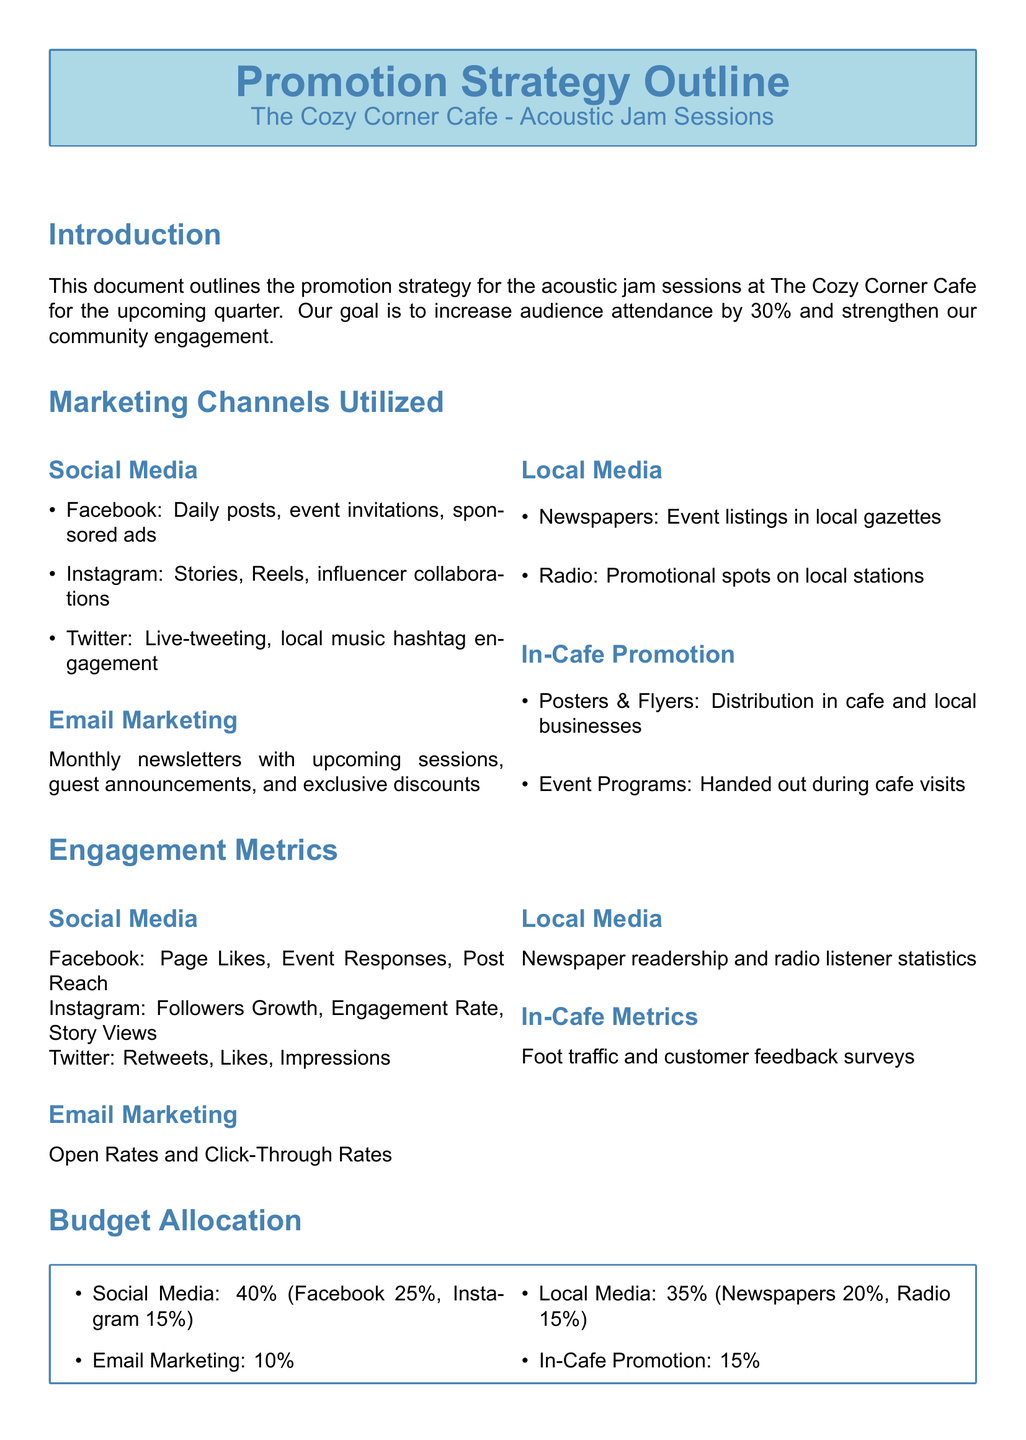What is the goal for audience attendance? The document states that the goal is to increase audience attendance by 30%.
Answer: 30% Which social media platform will receive the highest budget allocation? According to the budget allocation, Facebook will receive 25%, making it the highest.
Answer: Facebook What percentage of the budget is allocated to email marketing? The budget allocation specifies that email marketing will receive 10%.
Answer: 10% What engagement metric is used for Instagram? The document lists Followers Growth as one of the engagement metrics for Instagram.
Answer: Followers Growth How many marketing channels are listed in the document? The document outlines four marketing channels utilized for promotion.
Answer: Four What type of media will receive 20% of the budget allocation? The budget distribution indicates that newspapers will receive 20%.
Answer: Newspapers What kind of promotional materials are specified for in-cafe promotion? The document mentions posters and flyers as part of the in-cafe promotion strategy.
Answer: Posters & Flyers What are the engagement metrics for email marketing? The document specifies Open Rates and Click-Through Rates as metrics for email marketing.
Answer: Open Rates and Click-Through Rates Which platform involves influencer collaborations? The document states that Instagram involves influencer collaborations.
Answer: Instagram 